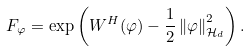<formula> <loc_0><loc_0><loc_500><loc_500>F _ { \varphi } = \exp \left ( W ^ { H } ( \varphi ) - \frac { 1 } { 2 } \left \| \varphi \right \| _ { \mathcal { H } _ { d } } ^ { 2 } \right ) .</formula> 